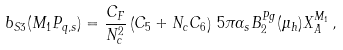Convert formula to latex. <formula><loc_0><loc_0><loc_500><loc_500>b _ { S 3 } ( M _ { 1 } P _ { q , s } ) = \frac { C _ { F } } { N _ { c } ^ { 2 } } \left ( C _ { 5 } + N _ { c } C _ { 6 } \right ) \, 5 \pi \alpha _ { s } B _ { 2 } ^ { P g } ( \mu _ { h } ) X _ { A } ^ { M _ { 1 } } \, ,</formula> 